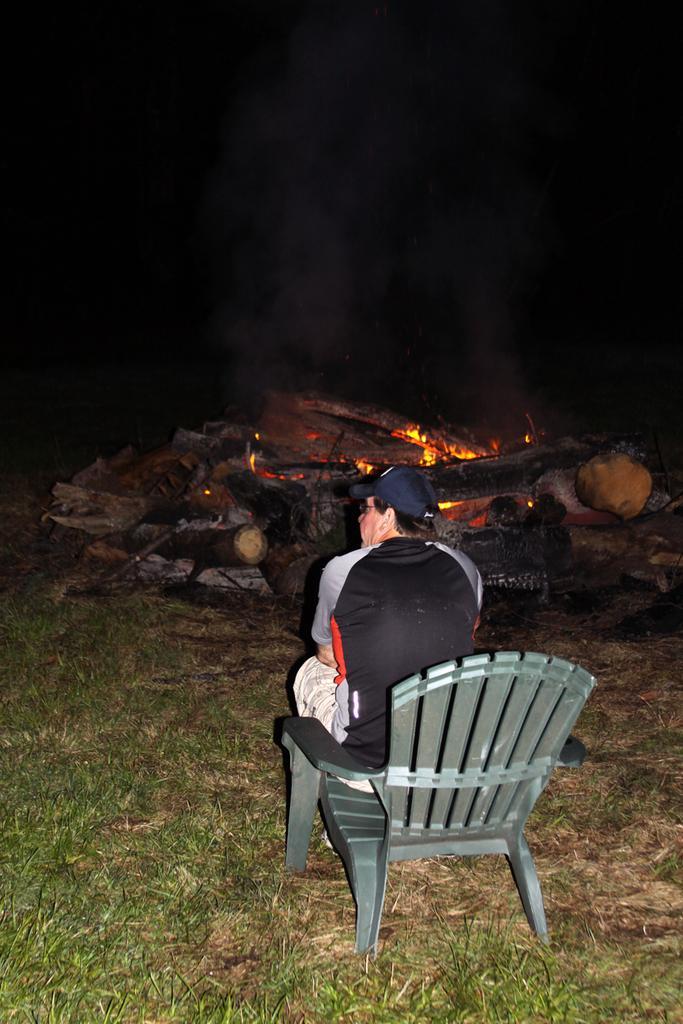How would you summarize this image in a sentence or two? In the foreground of this image, there is a man sitting on the chair on the ground. In the dark background, there is fire, sticks and smoke. On the left, there is the grass. 